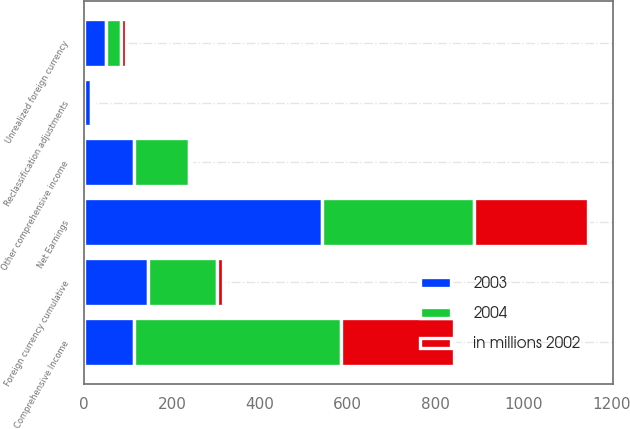<chart> <loc_0><loc_0><loc_500><loc_500><stacked_bar_chart><ecel><fcel>Net Earnings<fcel>Foreign currency cumulative<fcel>Unrealized foreign currency<fcel>Reclassification adjustments<fcel>Other comprehensive income<fcel>Comprehensive Income<nl><fcel>2003<fcel>541.8<fcel>145.5<fcel>48.7<fcel>15.7<fcel>114.6<fcel>114.6<nl><fcel>2004<fcel>346.3<fcel>156.6<fcel>35.3<fcel>3.4<fcel>124.7<fcel>471<nl><fcel>in millions 2002<fcel>257.8<fcel>13.5<fcel>12.2<fcel>3.5<fcel>2.8<fcel>255<nl></chart> 